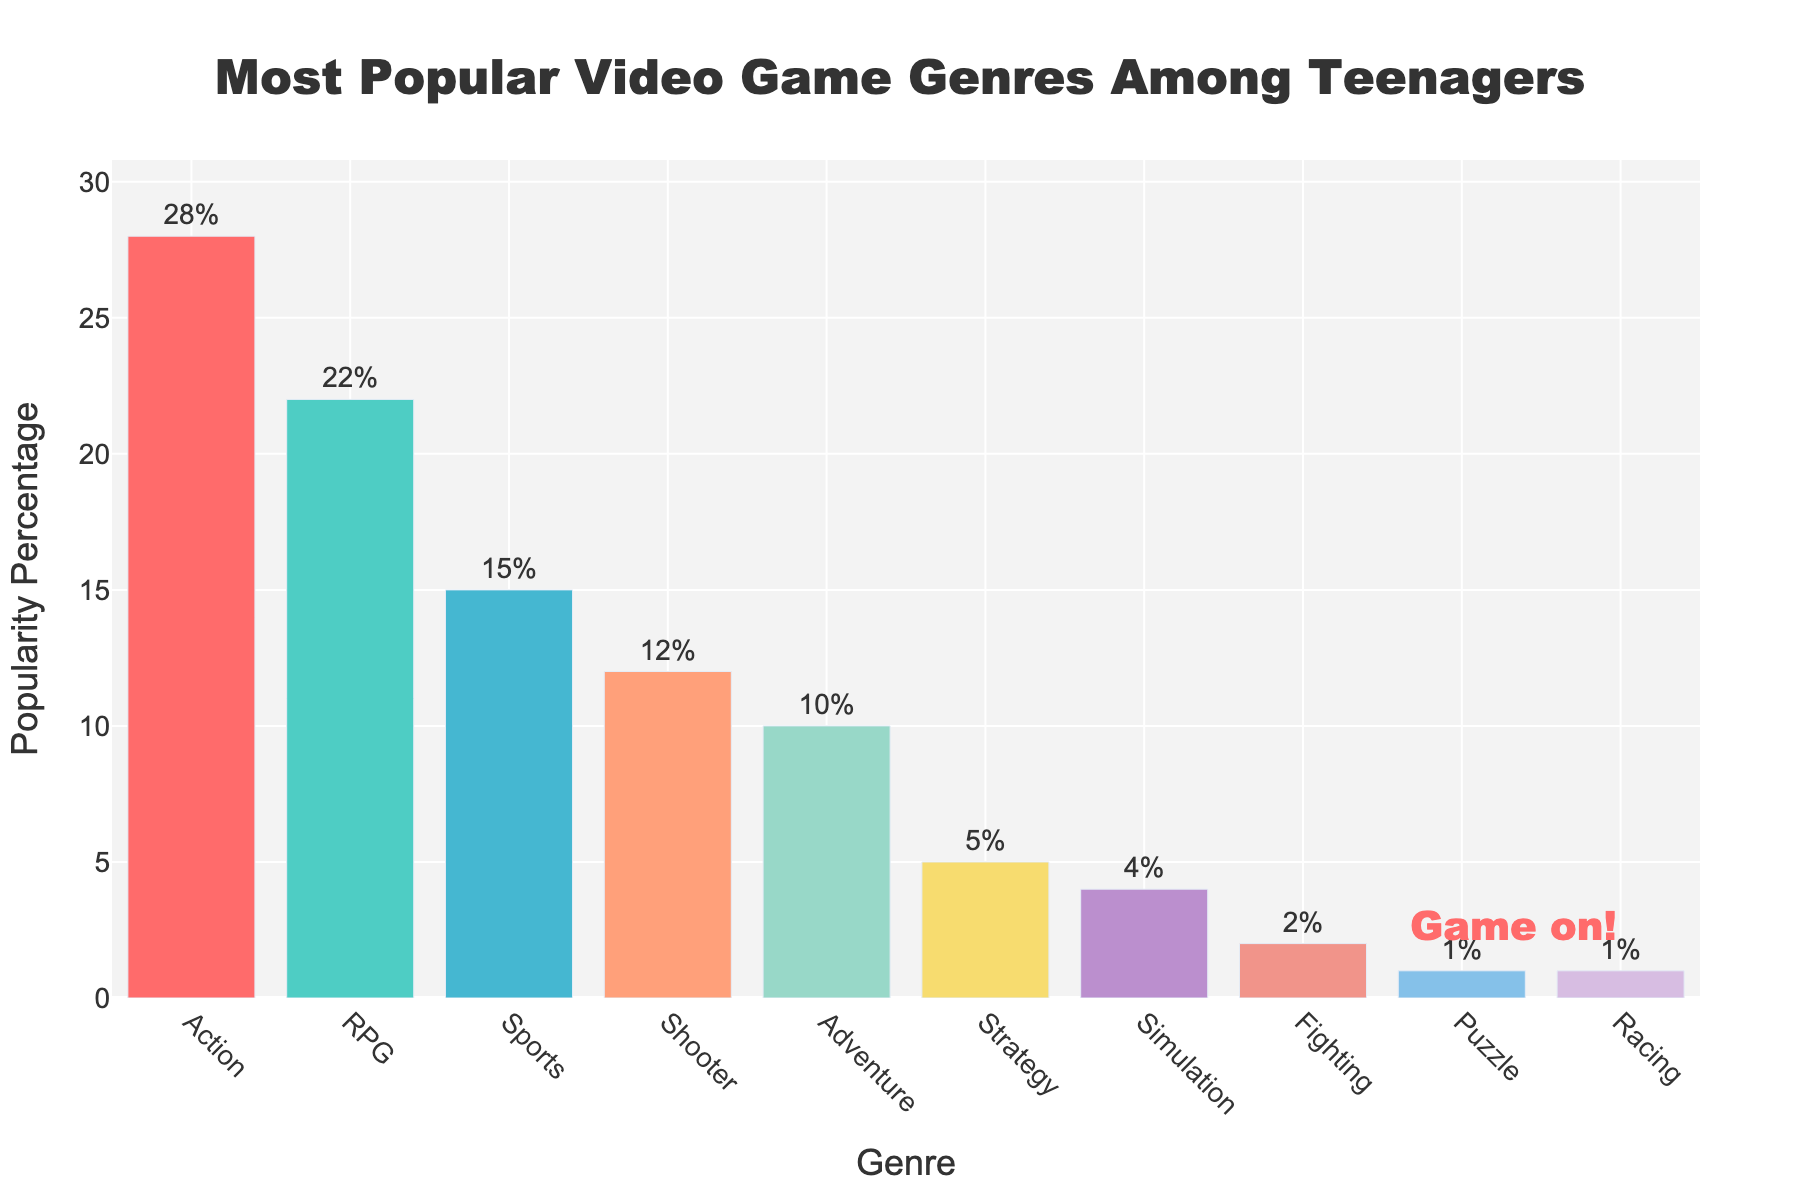Which genre is the most popular among teenagers? The bar representing the "Action" genre is the tallest, indicating it has the highest popularity percentage.
Answer: Action What is the combined percentage of the RPG and Sports genres? The popularity percentage for RPG is 22% and for Sports is 15%. Adding them together gives 22 + 15 = 37.
Answer: 37% Which genre has a higher popularity percentage, Shooter or Adventure? The bar for the "Shooter" genre is taller than the one for "Adventure," with Shooter at 12% and Adventure at 10%.
Answer: Shooter What is the difference in popularity percentage between the most popular genre and the least popular genre? The most popular genre (Action) has 28%, and the least popular genres (Puzzle and Racing) have 1% each. The difference is 28 - 1 = 27.
Answer: 27% What is the average popularity percentage of the top three genres? The top three genres are Action (28%), RPG (22%), and Sports (15%). The average is calculated by summing them up and dividing by 3: (28 + 22 + 15) / 3 = 65 / 3 ≈ 21.67.
Answer: 21.67% What is the total popularity percentage of genres with less than 10% popularity? The genres with less than 10% are Strategy (5%), Simulation (4%), Fighting (2%), Puzzle (1%), and Racing (1%). Adding them together gives 5 + 4 + 2 + 1 + 1 = 13.
Answer: 13% Which genres have the same popularity percentage? From the chart, the bars for "Puzzle" and "Racing" are at the same height, indicating they both have a popularity percentage of 1%.
Answer: Puzzle and Racing What percentage of teenagers prefer genres other than Action, RPG, and Sports? The percentages for Action, RPG, and Sports are 28%, 22%, and 15% respectively. Adding them up gives 28 + 22 + 15 = 65%. The percentage for other genres is 100% - 65% = 35%.
Answer: 35% Which genre has the lowest popularity percentage? The shortest bars in the chart represent "Puzzle" and "Racing," both at 1%.
Answer: Puzzle and Racing 